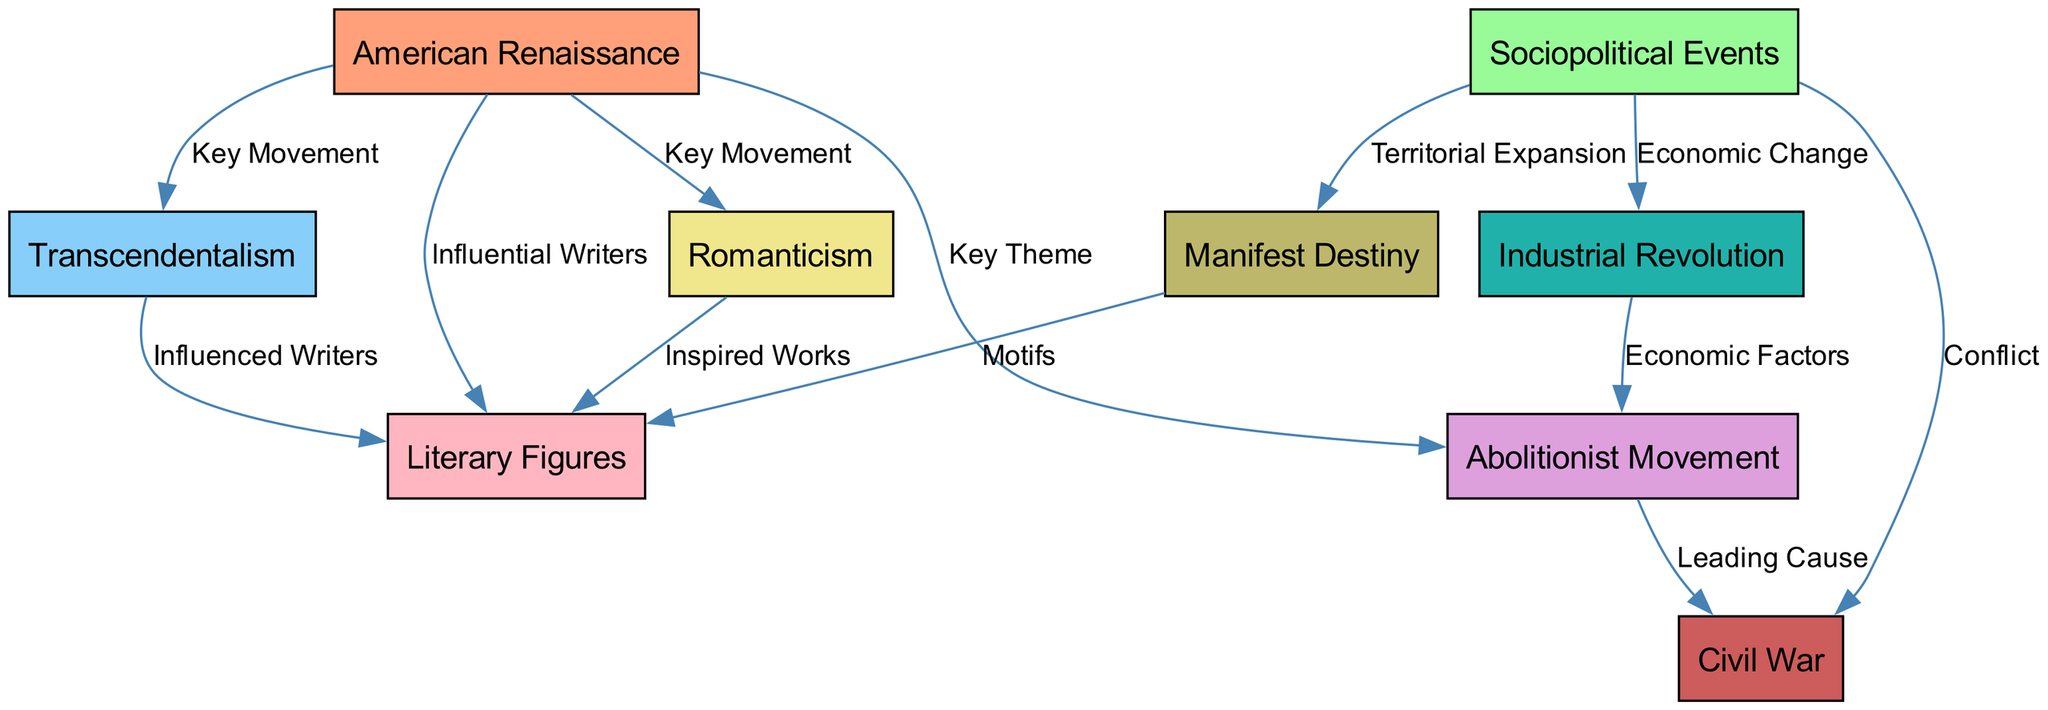What is the key movement associated with the American Renaissance? The diagram connects the American Renaissance node to the Transcendentalism node with the label "Key Movement," indicating that Transcendentalism is a key literary movement during this period.
Answer: Transcendentalism How many influential writers are connected to the American Renaissance? The diagram shows an edge from the American Renaissance node to the Literary Figures node labeled "Influential Writers," indicating that there are several writers associated with this movement. The node itself does not specify a number, but it suggests that this is a significant group.
Answer: Several Which sociopolitical event is labeled as a leading cause of the Civil War? The diagram indicates an edge from the Abolitionist Movement node to the Civil War node labeled "Leading Cause," suggesting that the Abolitionist Movement was a significant factor contributing to the Civil War.
Answer: Abolitionist Movement What economic change is linked to sociopolitical events in the diagram? There is a directed edge from Sociopolitical Events to the Industrial Revolution labeled "Economic Change," indicating that this was a notable economic transformation occurring alongside sociopolitical events.
Answer: Industrial Revolution Which literary movement inspired works linked to Romanticism? The diagram shows an edge from the Romanticism node to the Literary Figures node labeled "Inspired Works," indicating that Romanticism influenced the creation of literary works by various authors.
Answer: Literary Figures What motif links Manifest Destiny to literary figures? The diagram indicates an edge from Manifest Destiny to Literary Figures labeled "Motifs," illustrating that themes associated with Manifest Destiny appeared in the works of influential writers.
Answer: Motifs Which sociopolitical event is connected to territorial expansion? The diagram displays a connection from Sociopolitical Events to the Manifest Destiny node labeled "Territorial Expansion," indicating that Manifest Destiny is related to the broader sociopolitical themes of expansion during this period.
Answer: Territorial Expansion What key theme connects the American Renaissance to the Civil War? The edge from the American Renaissance to the Abolitionist Movement labeled "Key Theme" implies that the ideas and motifs expressed during the Renaissance, particularly related to human rights and freedom, were crucial themes leading up to the Civil War.
Answer: Key Theme 